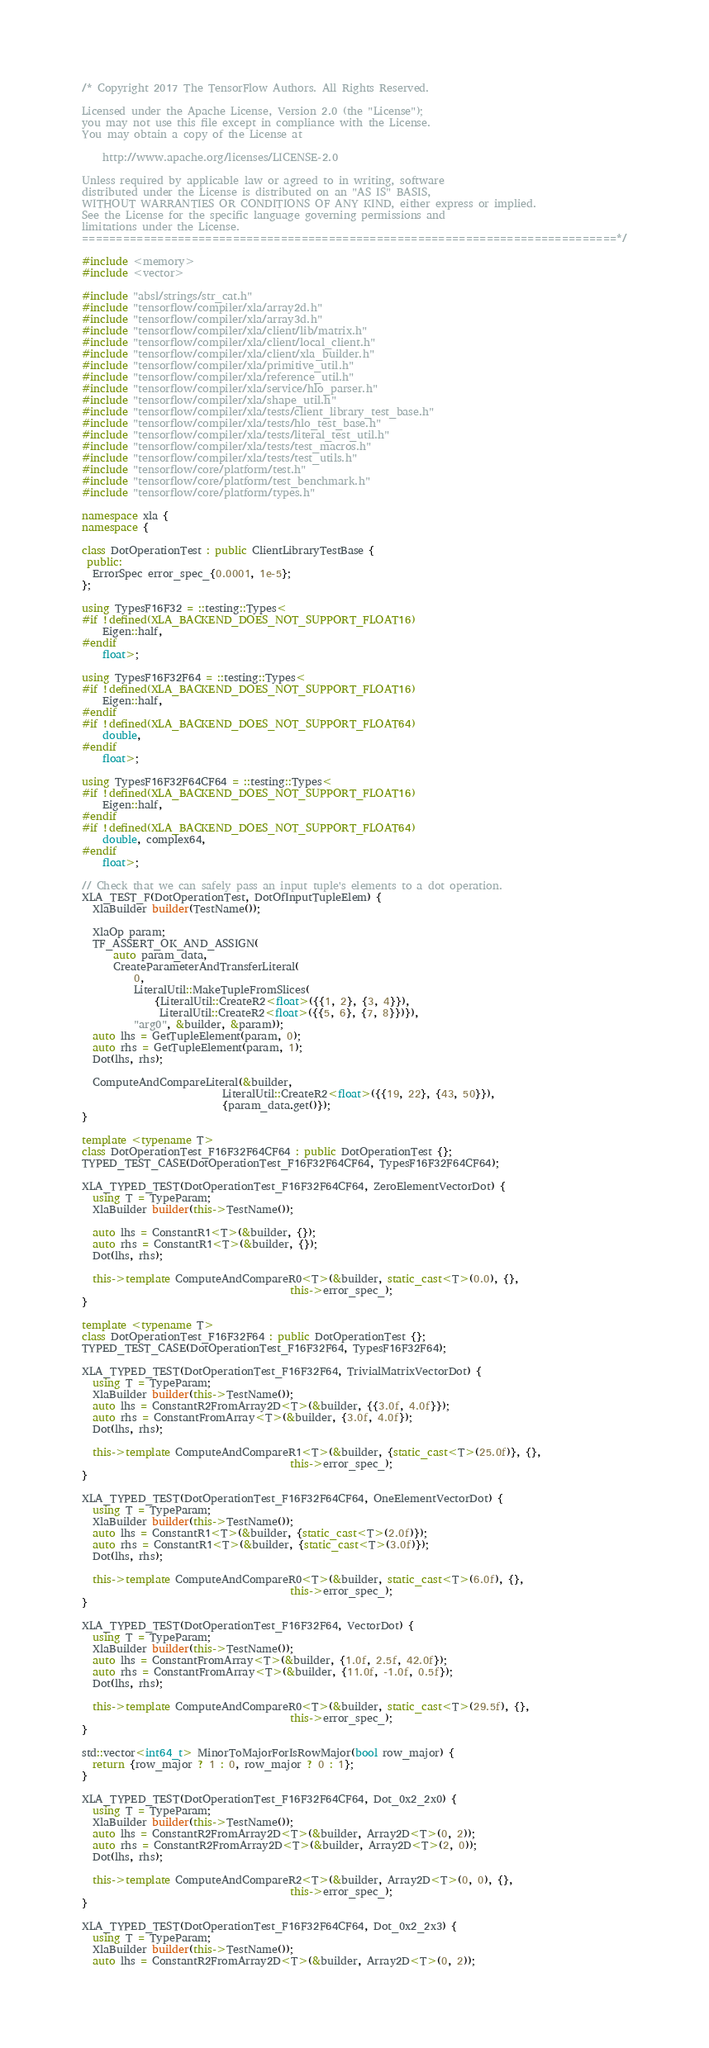<code> <loc_0><loc_0><loc_500><loc_500><_C++_>/* Copyright 2017 The TensorFlow Authors. All Rights Reserved.

Licensed under the Apache License, Version 2.0 (the "License");
you may not use this file except in compliance with the License.
You may obtain a copy of the License at

    http://www.apache.org/licenses/LICENSE-2.0

Unless required by applicable law or agreed to in writing, software
distributed under the License is distributed on an "AS IS" BASIS,
WITHOUT WARRANTIES OR CONDITIONS OF ANY KIND, either express or implied.
See the License for the specific language governing permissions and
limitations under the License.
==============================================================================*/

#include <memory>
#include <vector>

#include "absl/strings/str_cat.h"
#include "tensorflow/compiler/xla/array2d.h"
#include "tensorflow/compiler/xla/array3d.h"
#include "tensorflow/compiler/xla/client/lib/matrix.h"
#include "tensorflow/compiler/xla/client/local_client.h"
#include "tensorflow/compiler/xla/client/xla_builder.h"
#include "tensorflow/compiler/xla/primitive_util.h"
#include "tensorflow/compiler/xla/reference_util.h"
#include "tensorflow/compiler/xla/service/hlo_parser.h"
#include "tensorflow/compiler/xla/shape_util.h"
#include "tensorflow/compiler/xla/tests/client_library_test_base.h"
#include "tensorflow/compiler/xla/tests/hlo_test_base.h"
#include "tensorflow/compiler/xla/tests/literal_test_util.h"
#include "tensorflow/compiler/xla/tests/test_macros.h"
#include "tensorflow/compiler/xla/tests/test_utils.h"
#include "tensorflow/core/platform/test.h"
#include "tensorflow/core/platform/test_benchmark.h"
#include "tensorflow/core/platform/types.h"

namespace xla {
namespace {

class DotOperationTest : public ClientLibraryTestBase {
 public:
  ErrorSpec error_spec_{0.0001, 1e-5};
};

using TypesF16F32 = ::testing::Types<
#if !defined(XLA_BACKEND_DOES_NOT_SUPPORT_FLOAT16)
    Eigen::half,
#endif
    float>;

using TypesF16F32F64 = ::testing::Types<
#if !defined(XLA_BACKEND_DOES_NOT_SUPPORT_FLOAT16)
    Eigen::half,
#endif
#if !defined(XLA_BACKEND_DOES_NOT_SUPPORT_FLOAT64)
    double,
#endif
    float>;

using TypesF16F32F64CF64 = ::testing::Types<
#if !defined(XLA_BACKEND_DOES_NOT_SUPPORT_FLOAT16)
    Eigen::half,
#endif
#if !defined(XLA_BACKEND_DOES_NOT_SUPPORT_FLOAT64)
    double, complex64,
#endif
    float>;

// Check that we can safely pass an input tuple's elements to a dot operation.
XLA_TEST_F(DotOperationTest, DotOfInputTupleElem) {
  XlaBuilder builder(TestName());

  XlaOp param;
  TF_ASSERT_OK_AND_ASSIGN(
      auto param_data,
      CreateParameterAndTransferLiteral(
          0,
          LiteralUtil::MakeTupleFromSlices(
              {LiteralUtil::CreateR2<float>({{1, 2}, {3, 4}}),
               LiteralUtil::CreateR2<float>({{5, 6}, {7, 8}})}),
          "arg0", &builder, &param));
  auto lhs = GetTupleElement(param, 0);
  auto rhs = GetTupleElement(param, 1);
  Dot(lhs, rhs);

  ComputeAndCompareLiteral(&builder,
                           LiteralUtil::CreateR2<float>({{19, 22}, {43, 50}}),
                           {param_data.get()});
}

template <typename T>
class DotOperationTest_F16F32F64CF64 : public DotOperationTest {};
TYPED_TEST_CASE(DotOperationTest_F16F32F64CF64, TypesF16F32F64CF64);

XLA_TYPED_TEST(DotOperationTest_F16F32F64CF64, ZeroElementVectorDot) {
  using T = TypeParam;
  XlaBuilder builder(this->TestName());

  auto lhs = ConstantR1<T>(&builder, {});
  auto rhs = ConstantR1<T>(&builder, {});
  Dot(lhs, rhs);

  this->template ComputeAndCompareR0<T>(&builder, static_cast<T>(0.0), {},
                                        this->error_spec_);
}

template <typename T>
class DotOperationTest_F16F32F64 : public DotOperationTest {};
TYPED_TEST_CASE(DotOperationTest_F16F32F64, TypesF16F32F64);

XLA_TYPED_TEST(DotOperationTest_F16F32F64, TrivialMatrixVectorDot) {
  using T = TypeParam;
  XlaBuilder builder(this->TestName());
  auto lhs = ConstantR2FromArray2D<T>(&builder, {{3.0f, 4.0f}});
  auto rhs = ConstantFromArray<T>(&builder, {3.0f, 4.0f});
  Dot(lhs, rhs);

  this->template ComputeAndCompareR1<T>(&builder, {static_cast<T>(25.0f)}, {},
                                        this->error_spec_);
}

XLA_TYPED_TEST(DotOperationTest_F16F32F64CF64, OneElementVectorDot) {
  using T = TypeParam;
  XlaBuilder builder(this->TestName());
  auto lhs = ConstantR1<T>(&builder, {static_cast<T>(2.0f)});
  auto rhs = ConstantR1<T>(&builder, {static_cast<T>(3.0f)});
  Dot(lhs, rhs);

  this->template ComputeAndCompareR0<T>(&builder, static_cast<T>(6.0f), {},
                                        this->error_spec_);
}

XLA_TYPED_TEST(DotOperationTest_F16F32F64, VectorDot) {
  using T = TypeParam;
  XlaBuilder builder(this->TestName());
  auto lhs = ConstantFromArray<T>(&builder, {1.0f, 2.5f, 42.0f});
  auto rhs = ConstantFromArray<T>(&builder, {11.0f, -1.0f, 0.5f});
  Dot(lhs, rhs);

  this->template ComputeAndCompareR0<T>(&builder, static_cast<T>(29.5f), {},
                                        this->error_spec_);
}

std::vector<int64_t> MinorToMajorForIsRowMajor(bool row_major) {
  return {row_major ? 1 : 0, row_major ? 0 : 1};
}

XLA_TYPED_TEST(DotOperationTest_F16F32F64CF64, Dot_0x2_2x0) {
  using T = TypeParam;
  XlaBuilder builder(this->TestName());
  auto lhs = ConstantR2FromArray2D<T>(&builder, Array2D<T>(0, 2));
  auto rhs = ConstantR2FromArray2D<T>(&builder, Array2D<T>(2, 0));
  Dot(lhs, rhs);

  this->template ComputeAndCompareR2<T>(&builder, Array2D<T>(0, 0), {},
                                        this->error_spec_);
}

XLA_TYPED_TEST(DotOperationTest_F16F32F64CF64, Dot_0x2_2x3) {
  using T = TypeParam;
  XlaBuilder builder(this->TestName());
  auto lhs = ConstantR2FromArray2D<T>(&builder, Array2D<T>(0, 2));</code> 